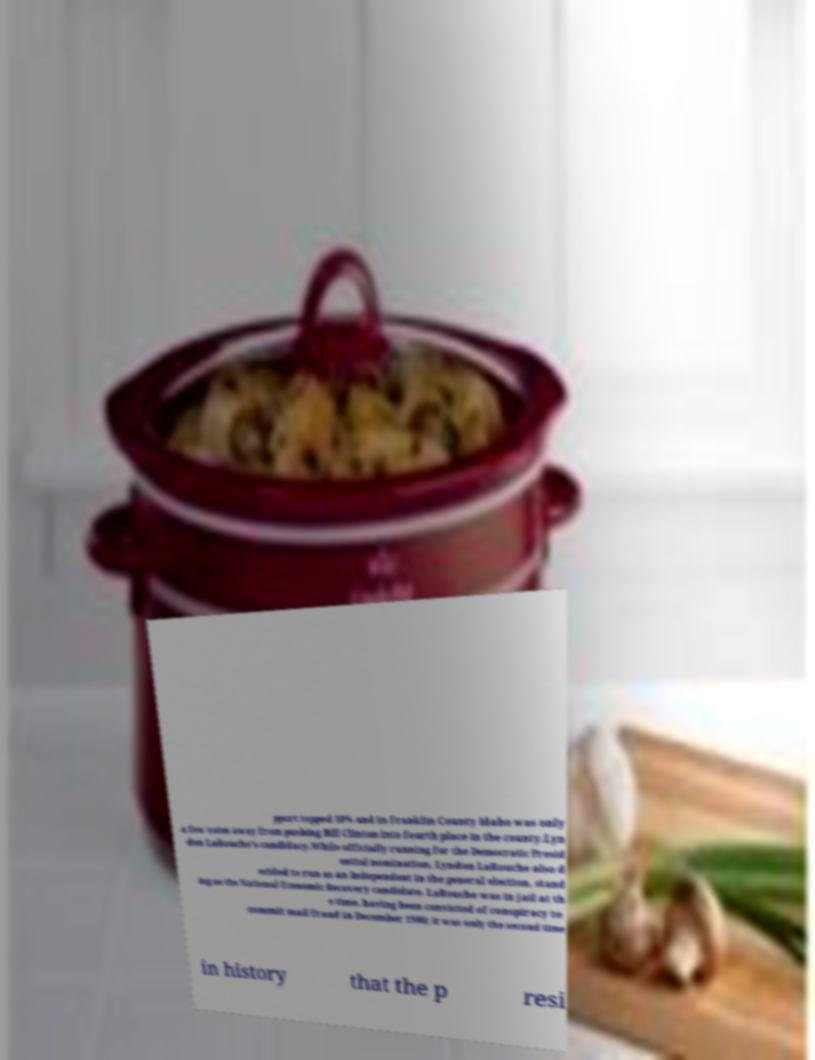Please identify and transcribe the text found in this image. pport topped 10% and in Franklin County Idaho was only a few votes away from pushing Bill Clinton into fourth place in the county.Lyn don LaRouche's candidacy.While officially running for the Democratic Presid ential nomination, Lyndon LaRouche also d ecided to run as an Independent in the general election, stand ing as the National Economic Recovery candidate. LaRouche was in jail at th e time, having been convicted of conspiracy to commit mail fraud in December 1988; it was only the second time in history that the p resi 